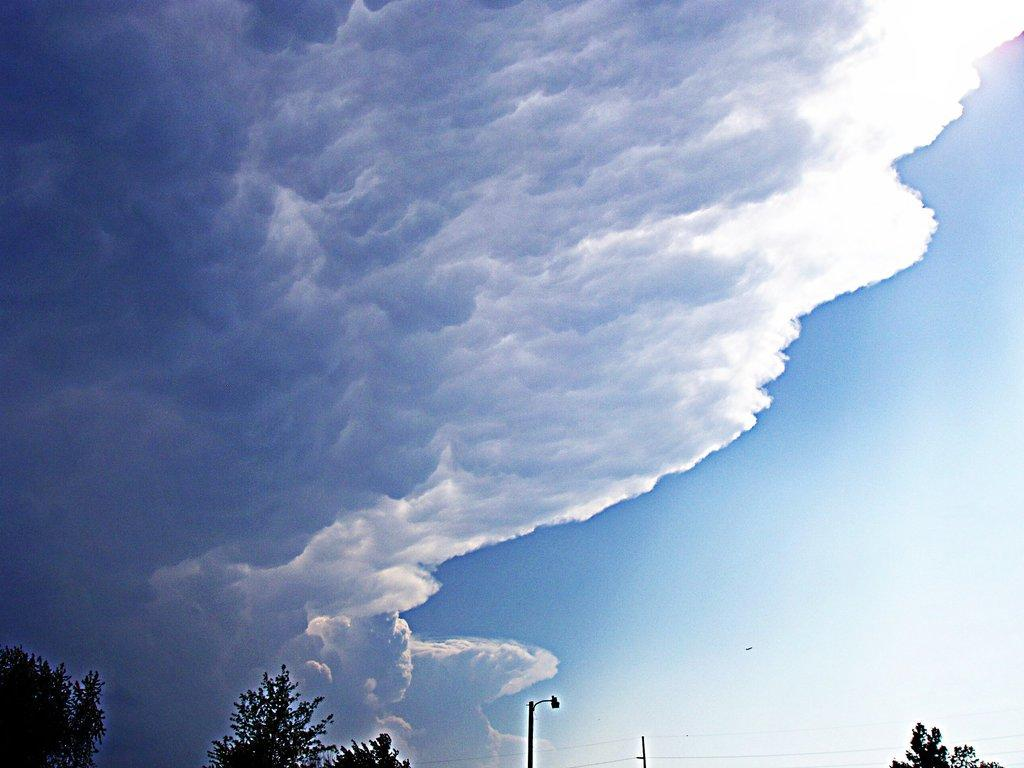What type of vegetation is present in the image? There are many trees in the image. What else can be seen in the image besides trees? There are poles in the visible in the image. What is visible in the background of the image? Clouds and a blue sky are visible in the background of the image. What type of jar is hanging from the frame in the image? There is no jar or frame present in the image; it only features trees and poles with a blue sky and clouds in the background. 